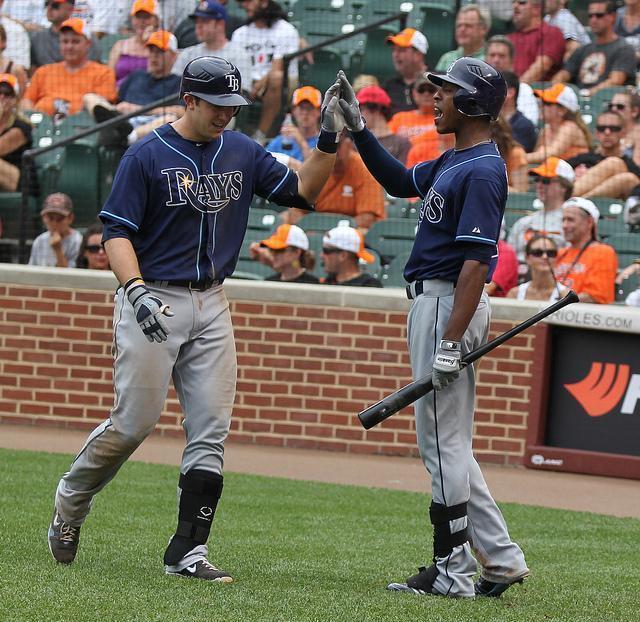How many people are in the picture?
Give a very brief answer. 11. 